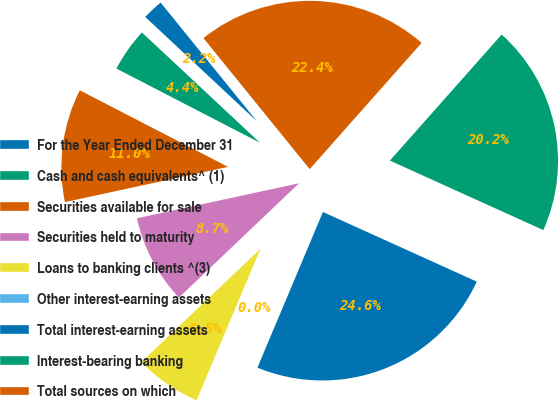<chart> <loc_0><loc_0><loc_500><loc_500><pie_chart><fcel>For the Year Ended December 31<fcel>Cash and cash equivalents^ (1)<fcel>Securities available for sale<fcel>Securities held to maturity<fcel>Loans to banking clients ^(3)<fcel>Other interest-earning assets<fcel>Total interest-earning assets<fcel>Interest-bearing banking<fcel>Total sources on which<nl><fcel>2.19%<fcel>4.37%<fcel>10.98%<fcel>8.72%<fcel>6.54%<fcel>0.01%<fcel>24.57%<fcel>20.22%<fcel>22.39%<nl></chart> 